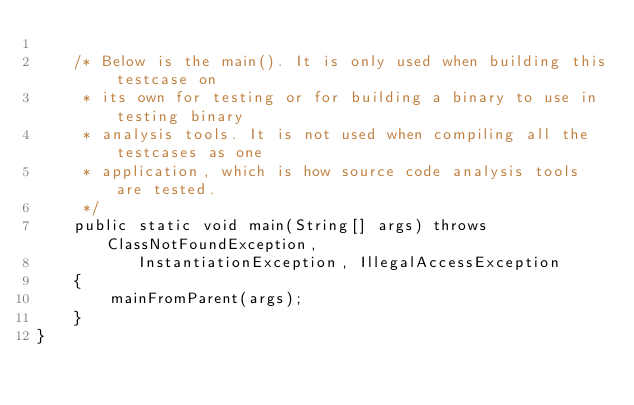Convert code to text. <code><loc_0><loc_0><loc_500><loc_500><_Java_>
    /* Below is the main(). It is only used when building this testcase on
     * its own for testing or for building a binary to use in testing binary
     * analysis tools. It is not used when compiling all the testcases as one
     * application, which is how source code analysis tools are tested.
     */
    public static void main(String[] args) throws ClassNotFoundException,
           InstantiationException, IllegalAccessException
    {
        mainFromParent(args);
    }
}
</code> 